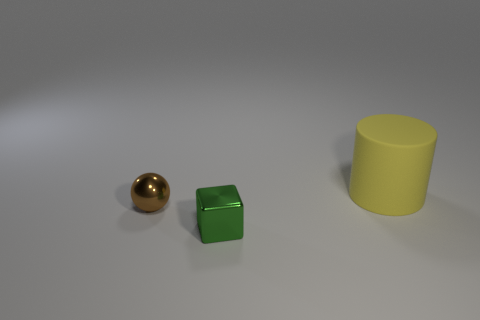Add 2 yellow cylinders. How many objects exist? 5 Subtract all blocks. How many objects are left? 2 Add 3 green cubes. How many green cubes are left? 4 Add 3 large rubber cylinders. How many large rubber cylinders exist? 4 Subtract 1 brown balls. How many objects are left? 2 Subtract all large blue matte objects. Subtract all yellow objects. How many objects are left? 2 